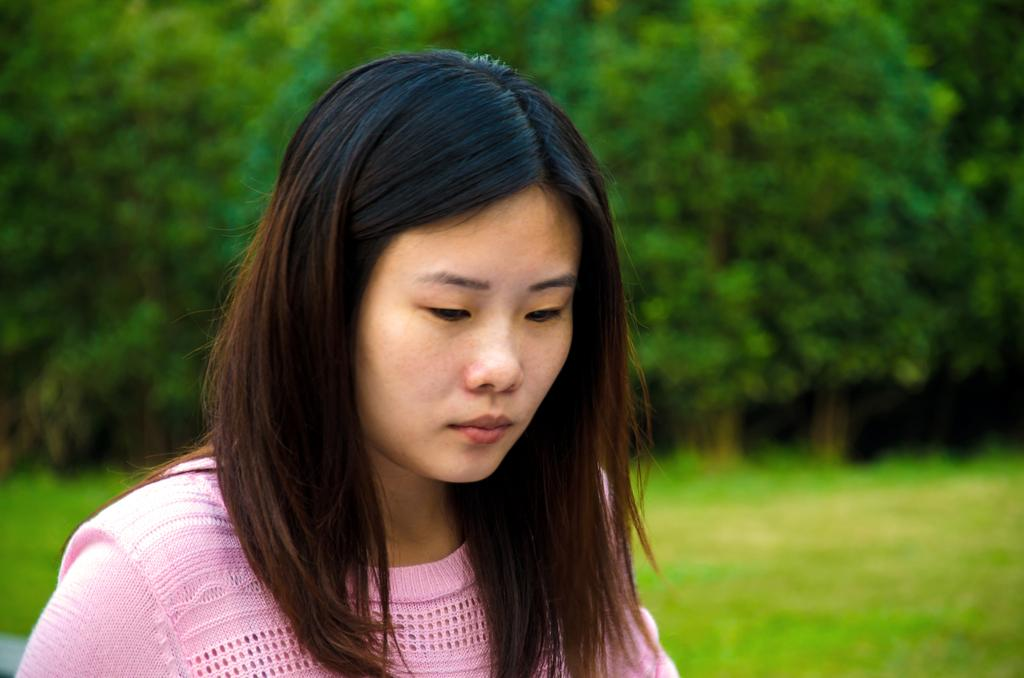Who is the main subject in the image? There is a lady in the image. What is the lady wearing? The lady is wearing a pink dress. What type of ground is visible behind the lady? There is grass on the ground behind the lady. What can be seen in the distance in the image? There are trees in the background of the image. What type of support is the lady using to climb the tree in the image? There is no tree or support visible in the image; the lady is not climbing anything. 